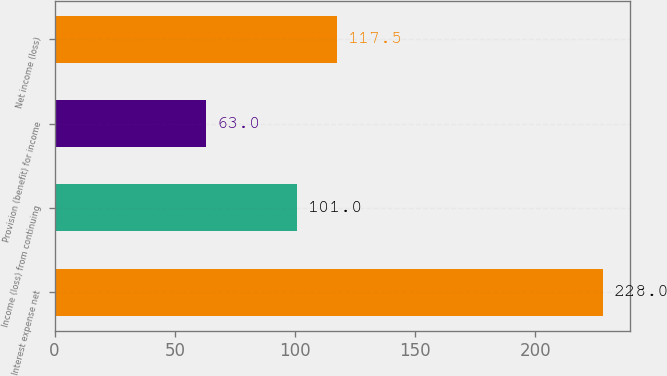Convert chart. <chart><loc_0><loc_0><loc_500><loc_500><bar_chart><fcel>Interest expense net<fcel>Income (loss) from continuing<fcel>Provision (benefit) for income<fcel>Net income (loss)<nl><fcel>228<fcel>101<fcel>63<fcel>117.5<nl></chart> 